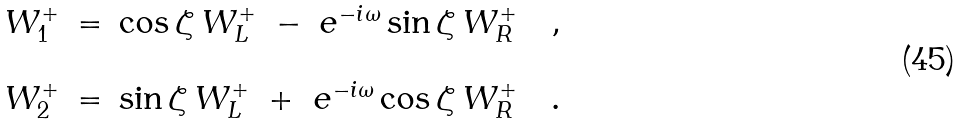Convert formula to latex. <formula><loc_0><loc_0><loc_500><loc_500>\begin{array} { c c l } W _ { 1 } ^ { + } & = & \cos \zeta \, W _ { L } ^ { + } \ - \ e ^ { - i \omega } \sin \zeta \, W _ { R } ^ { + } \quad , \\ \\ W _ { 2 } ^ { + } & = & \sin \zeta \, W _ { L } ^ { + } \ + \ e ^ { - i \omega } \cos \zeta \, W _ { R } ^ { + } \quad . \end{array}</formula> 